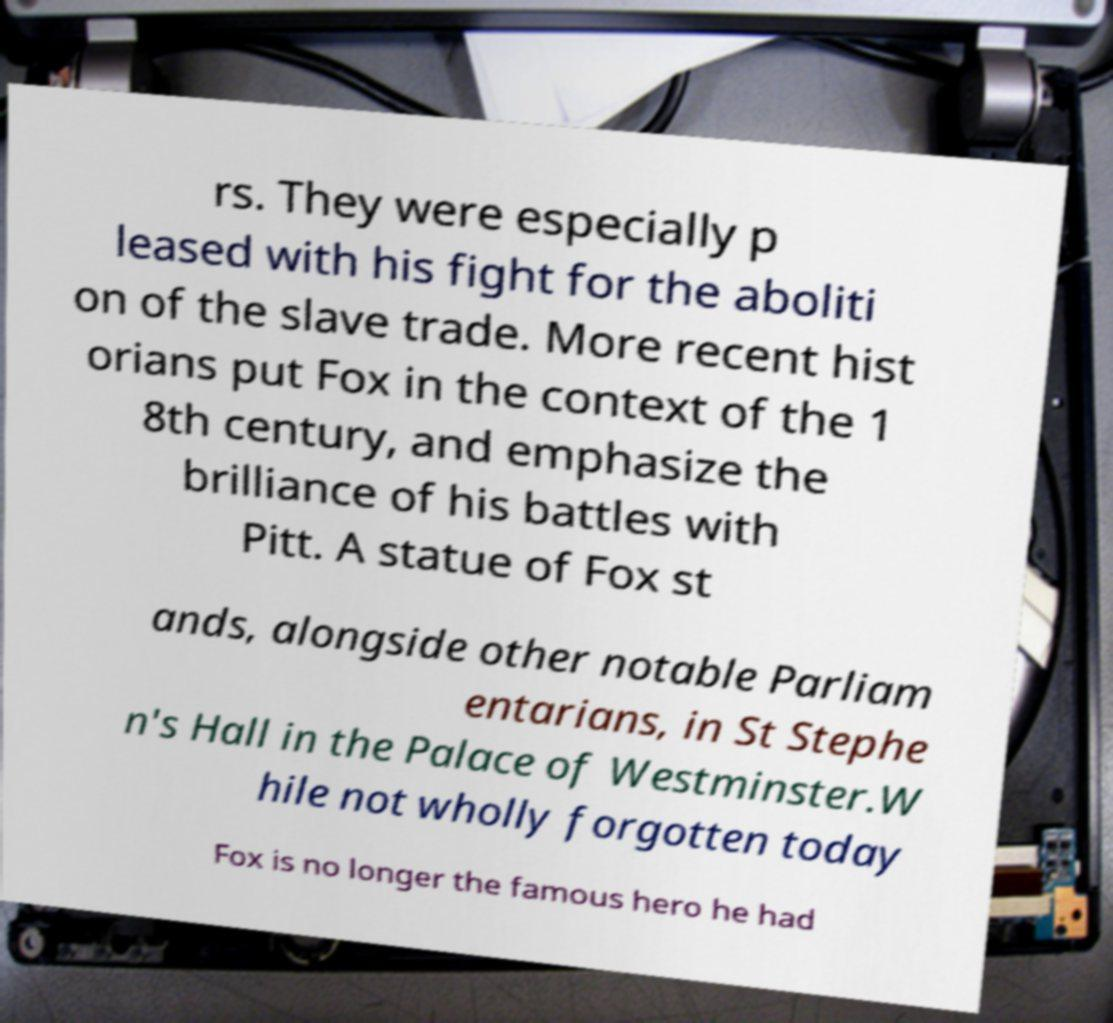Please read and relay the text visible in this image. What does it say? rs. They were especially p leased with his fight for the aboliti on of the slave trade. More recent hist orians put Fox in the context of the 1 8th century, and emphasize the brilliance of his battles with Pitt. A statue of Fox st ands, alongside other notable Parliam entarians, in St Stephe n's Hall in the Palace of Westminster.W hile not wholly forgotten today Fox is no longer the famous hero he had 